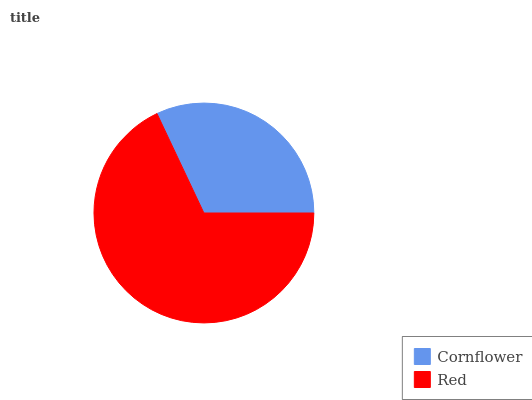Is Cornflower the minimum?
Answer yes or no. Yes. Is Red the maximum?
Answer yes or no. Yes. Is Red the minimum?
Answer yes or no. No. Is Red greater than Cornflower?
Answer yes or no. Yes. Is Cornflower less than Red?
Answer yes or no. Yes. Is Cornflower greater than Red?
Answer yes or no. No. Is Red less than Cornflower?
Answer yes or no. No. Is Red the high median?
Answer yes or no. Yes. Is Cornflower the low median?
Answer yes or no. Yes. Is Cornflower the high median?
Answer yes or no. No. Is Red the low median?
Answer yes or no. No. 